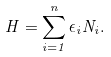<formula> <loc_0><loc_0><loc_500><loc_500>H = \sum _ { i = 1 } ^ { n } \epsilon _ { i } N _ { i } .</formula> 